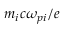Convert formula to latex. <formula><loc_0><loc_0><loc_500><loc_500>m _ { i } c \omega _ { p i } / e</formula> 